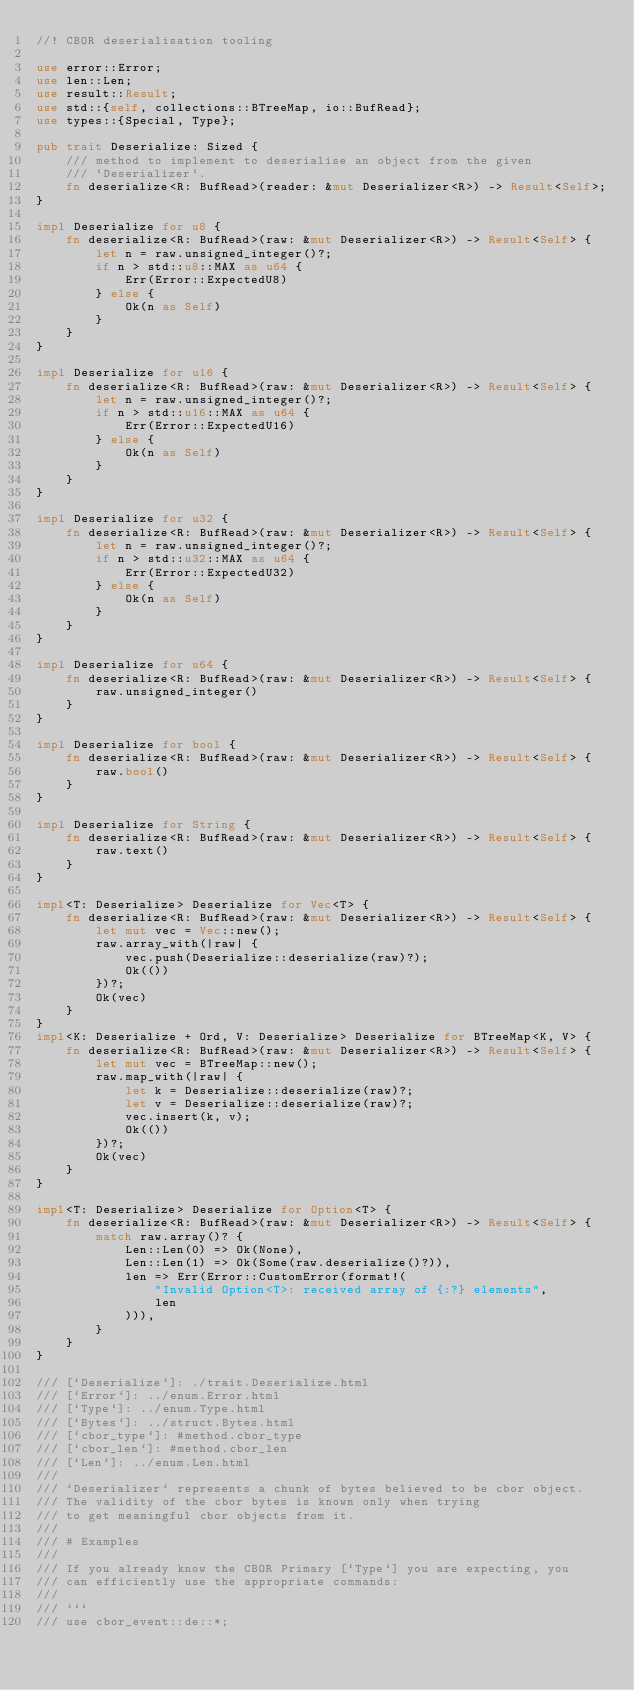<code> <loc_0><loc_0><loc_500><loc_500><_Rust_>//! CBOR deserialisation tooling

use error::Error;
use len::Len;
use result::Result;
use std::{self, collections::BTreeMap, io::BufRead};
use types::{Special, Type};

pub trait Deserialize: Sized {
    /// method to implement to deserialise an object from the given
    /// `Deserializer`.
    fn deserialize<R: BufRead>(reader: &mut Deserializer<R>) -> Result<Self>;
}

impl Deserialize for u8 {
    fn deserialize<R: BufRead>(raw: &mut Deserializer<R>) -> Result<Self> {
        let n = raw.unsigned_integer()?;
        if n > std::u8::MAX as u64 {
            Err(Error::ExpectedU8)
        } else {
            Ok(n as Self)
        }
    }
}

impl Deserialize for u16 {
    fn deserialize<R: BufRead>(raw: &mut Deserializer<R>) -> Result<Self> {
        let n = raw.unsigned_integer()?;
        if n > std::u16::MAX as u64 {
            Err(Error::ExpectedU16)
        } else {
            Ok(n as Self)
        }
    }
}

impl Deserialize for u32 {
    fn deserialize<R: BufRead>(raw: &mut Deserializer<R>) -> Result<Self> {
        let n = raw.unsigned_integer()?;
        if n > std::u32::MAX as u64 {
            Err(Error::ExpectedU32)
        } else {
            Ok(n as Self)
        }
    }
}

impl Deserialize for u64 {
    fn deserialize<R: BufRead>(raw: &mut Deserializer<R>) -> Result<Self> {
        raw.unsigned_integer()
    }
}

impl Deserialize for bool {
    fn deserialize<R: BufRead>(raw: &mut Deserializer<R>) -> Result<Self> {
        raw.bool()
    }
}

impl Deserialize for String {
    fn deserialize<R: BufRead>(raw: &mut Deserializer<R>) -> Result<Self> {
        raw.text()
    }
}

impl<T: Deserialize> Deserialize for Vec<T> {
    fn deserialize<R: BufRead>(raw: &mut Deserializer<R>) -> Result<Self> {
        let mut vec = Vec::new();
        raw.array_with(|raw| {
            vec.push(Deserialize::deserialize(raw)?);
            Ok(())
        })?;
        Ok(vec)
    }
}
impl<K: Deserialize + Ord, V: Deserialize> Deserialize for BTreeMap<K, V> {
    fn deserialize<R: BufRead>(raw: &mut Deserializer<R>) -> Result<Self> {
        let mut vec = BTreeMap::new();
        raw.map_with(|raw| {
            let k = Deserialize::deserialize(raw)?;
            let v = Deserialize::deserialize(raw)?;
            vec.insert(k, v);
            Ok(())
        })?;
        Ok(vec)
    }
}

impl<T: Deserialize> Deserialize for Option<T> {
    fn deserialize<R: BufRead>(raw: &mut Deserializer<R>) -> Result<Self> {
        match raw.array()? {
            Len::Len(0) => Ok(None),
            Len::Len(1) => Ok(Some(raw.deserialize()?)),
            len => Err(Error::CustomError(format!(
                "Invalid Option<T>: received array of {:?} elements",
                len
            ))),
        }
    }
}

/// [`Deserialize`]: ./trait.Deserialize.html
/// [`Error`]: ../enum.Error.html
/// [`Type`]: ../enum.Type.html
/// [`Bytes`]: ../struct.Bytes.html
/// [`cbor_type`]: #method.cbor_type
/// [`cbor_len`]: #method.cbor_len
/// [`Len`]: ../enum.Len.html
///
/// `Deserializer` represents a chunk of bytes believed to be cbor object.
/// The validity of the cbor bytes is known only when trying
/// to get meaningful cbor objects from it.
///
/// # Examples
///
/// If you already know the CBOR Primary [`Type`] you are expecting, you
/// can efficiently use the appropriate commands:
///
/// ```
/// use cbor_event::de::*;</code> 